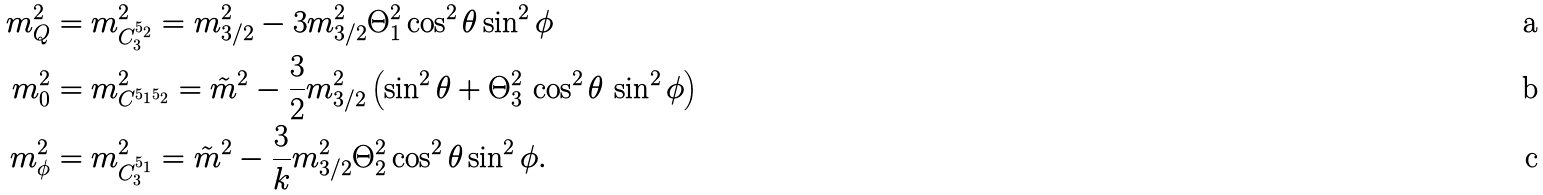Convert formula to latex. <formula><loc_0><loc_0><loc_500><loc_500>m _ { Q } ^ { 2 } & = m _ { C ^ { 5 _ { 2 } } _ { 3 } } ^ { 2 } = m _ { 3 / 2 } ^ { 2 } - 3 m _ { 3 / 2 } ^ { 2 } \Theta _ { 1 } ^ { 2 } \cos ^ { 2 } \theta \sin ^ { 2 } \phi \\ m _ { 0 } ^ { 2 } & = m _ { C ^ { 5 _ { 1 } 5 _ { 2 } } } ^ { 2 } = \tilde { m } ^ { 2 } - \frac { 3 } { 2 } m _ { 3 / 2 } ^ { 2 } \left ( \sin ^ { 2 } \theta + \Theta _ { 3 } ^ { 2 } \, \cos ^ { 2 } \theta \, \sin ^ { 2 } \phi \right ) \\ m _ { \phi } ^ { 2 } & = m _ { C ^ { 5 _ { 1 } } _ { 3 } } ^ { 2 } = \tilde { m } ^ { 2 } - \frac { 3 } { k } m _ { 3 / 2 } ^ { 2 } \Theta _ { 2 } ^ { 2 } \cos ^ { 2 } \theta \sin ^ { 2 } \phi .</formula> 